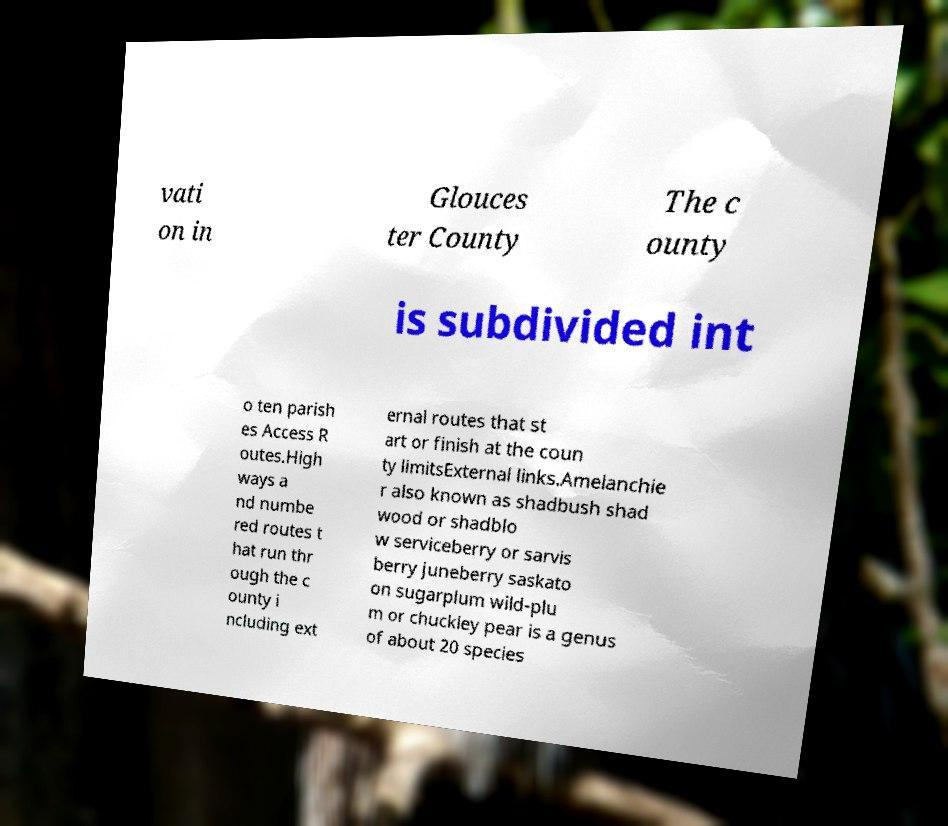I need the written content from this picture converted into text. Can you do that? vati on in Glouces ter County The c ounty is subdivided int o ten parish es Access R outes.High ways a nd numbe red routes t hat run thr ough the c ounty i ncluding ext ernal routes that st art or finish at the coun ty limitsExternal links.Amelanchie r also known as shadbush shad wood or shadblo w serviceberry or sarvis berry juneberry saskato on sugarplum wild-plu m or chuckley pear is a genus of about 20 species 